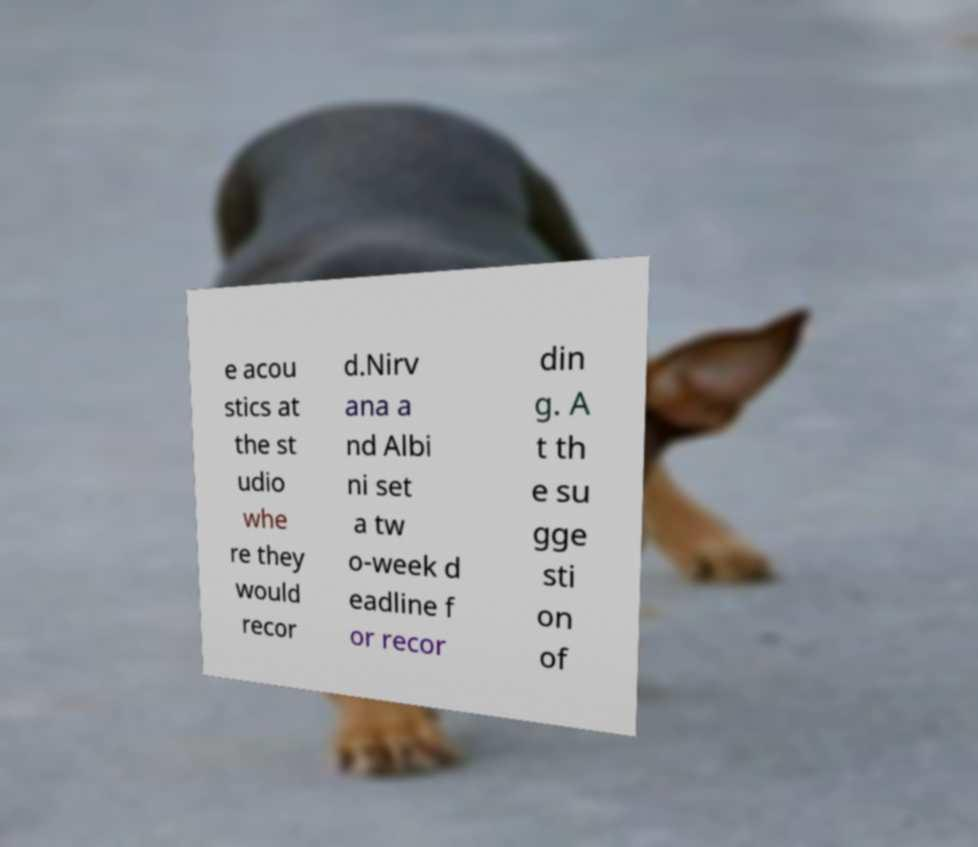Please identify and transcribe the text found in this image. e acou stics at the st udio whe re they would recor d.Nirv ana a nd Albi ni set a tw o-week d eadline f or recor din g. A t th e su gge sti on of 